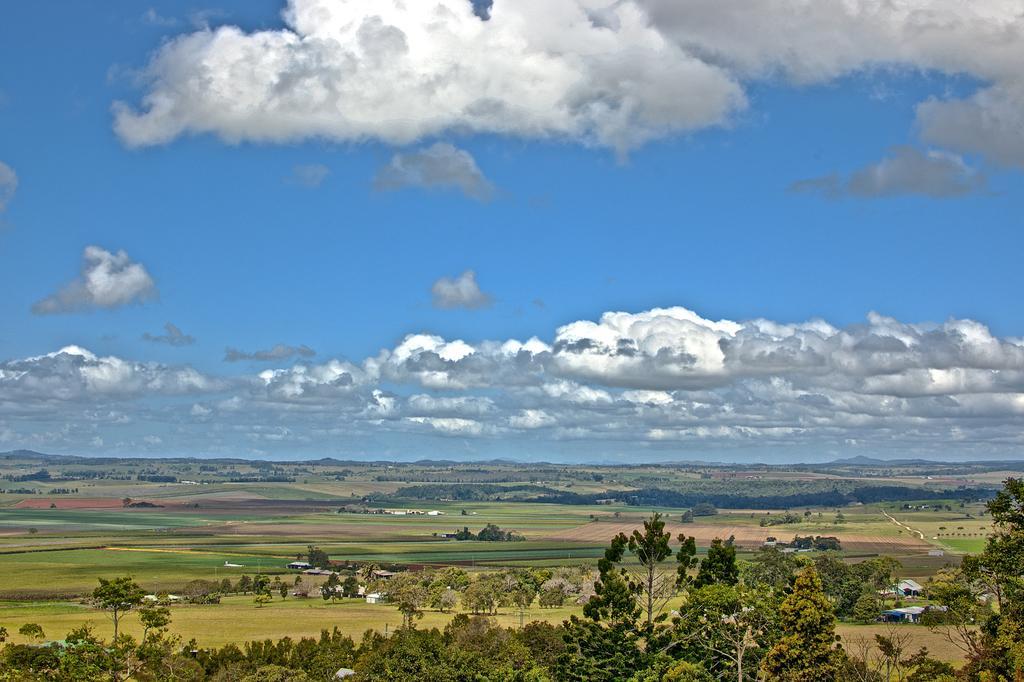How would you summarize this image in a sentence or two? At the bottom of the image there are trees, grass and houses. At the top of the image there is a cloudy sky. 